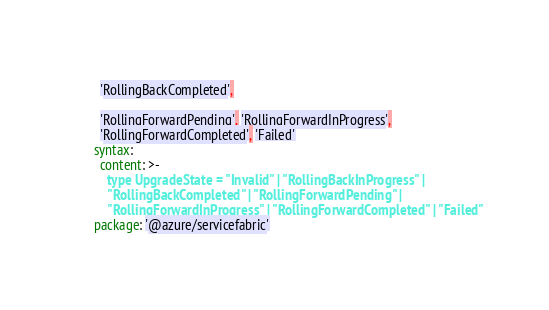<code> <loc_0><loc_0><loc_500><loc_500><_YAML_>      'RollingBackCompleted',

      'RollingForwardPending', 'RollingForwardInProgress',
      'RollingForwardCompleted', 'Failed'
    syntax:
      content: >-
        type UpgradeState = "Invalid" | "RollingBackInProgress" |
        "RollingBackCompleted" | "RollingForwardPending" |
        "RollingForwardInProgress" | "RollingForwardCompleted" | "Failed"
    package: '@azure/servicefabric'
</code> 